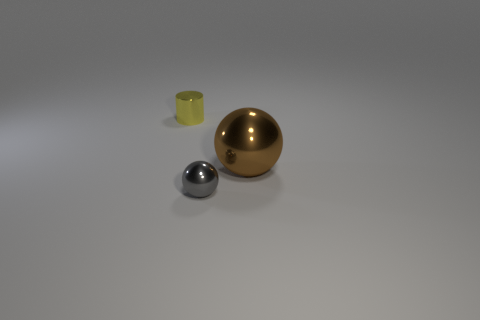Add 2 yellow things. How many objects exist? 5 Subtract all balls. How many objects are left? 1 Subtract 0 purple blocks. How many objects are left? 3 Subtract all brown spheres. Subtract all tiny cyan shiny cylinders. How many objects are left? 2 Add 2 big shiny things. How many big shiny things are left? 3 Add 1 blue rubber blocks. How many blue rubber blocks exist? 1 